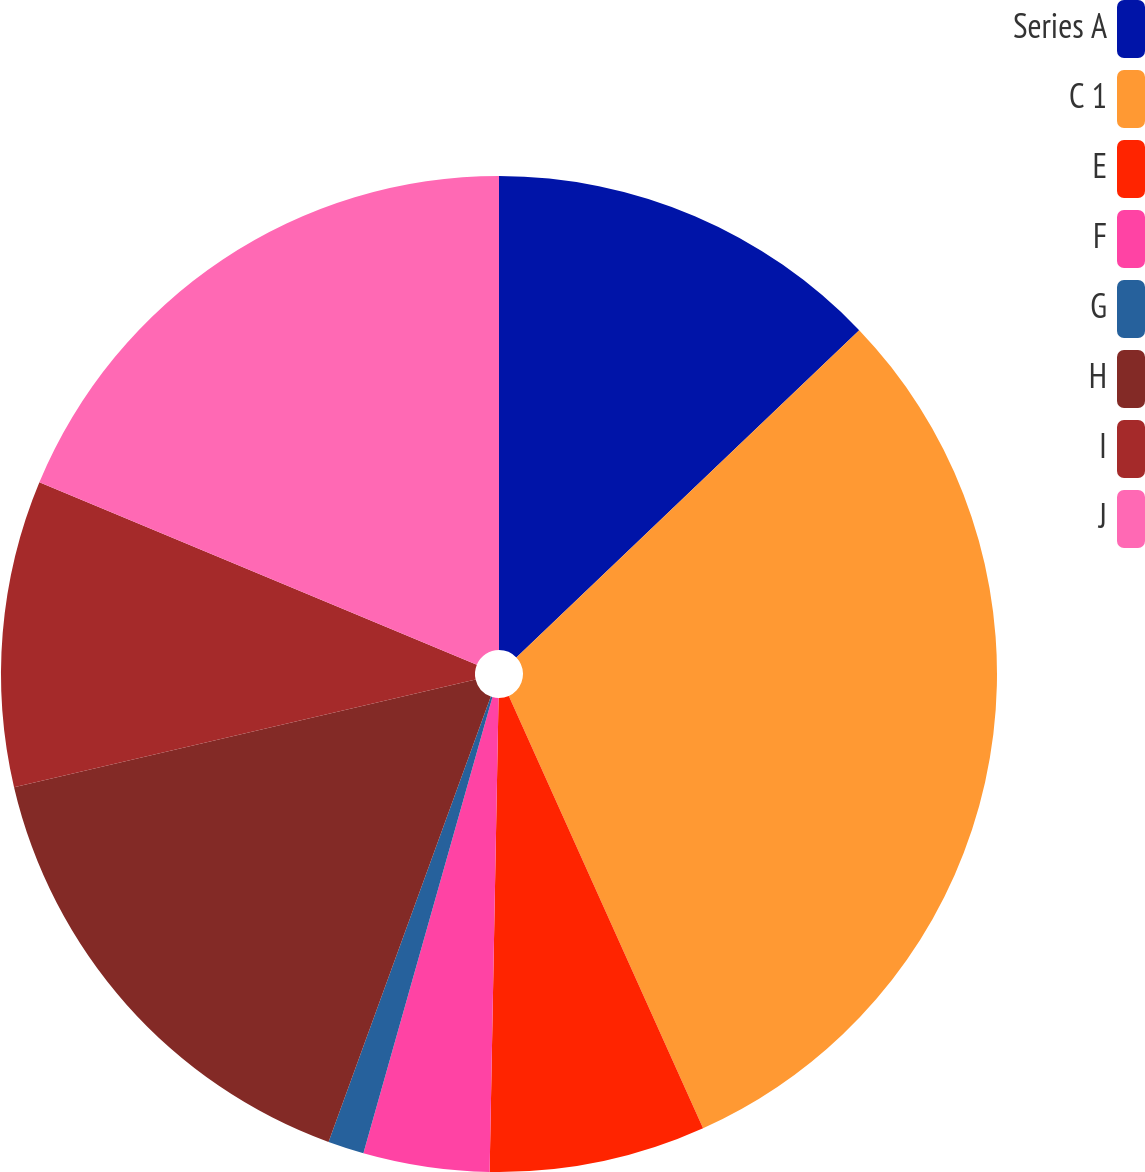<chart> <loc_0><loc_0><loc_500><loc_500><pie_chart><fcel>Series A<fcel>C 1<fcel>E<fcel>F<fcel>G<fcel>H<fcel>I<fcel>J<nl><fcel>12.87%<fcel>30.41%<fcel>7.02%<fcel>4.09%<fcel>1.17%<fcel>15.79%<fcel>9.94%<fcel>18.71%<nl></chart> 